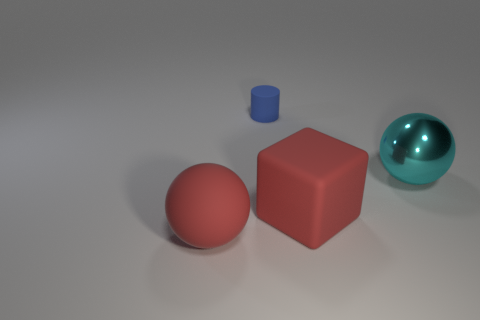Are there any other things that are the same size as the cylinder?
Your response must be concise. No. There is a tiny blue cylinder; how many large spheres are to the right of it?
Keep it short and to the point. 1. What number of things are large yellow rubber balls or objects to the right of the small blue matte cylinder?
Offer a very short reply. 2. There is a large ball to the right of the big red rubber ball; are there any large cyan objects left of it?
Keep it short and to the point. No. There is a big object behind the red matte block; what is its color?
Provide a short and direct response. Cyan. Are there an equal number of blue objects behind the big matte block and large cubes?
Provide a succinct answer. Yes. There is a big thing that is both left of the large cyan sphere and on the right side of the blue cylinder; what shape is it?
Your answer should be very brief. Cube. There is a matte thing that is the same shape as the big cyan metallic object; what color is it?
Your answer should be very brief. Red. Is there any other thing of the same color as the matte sphere?
Offer a very short reply. Yes. There is a red matte object that is behind the large red object that is on the left side of the matte thing to the right of the tiny cylinder; what shape is it?
Your answer should be compact. Cube. 